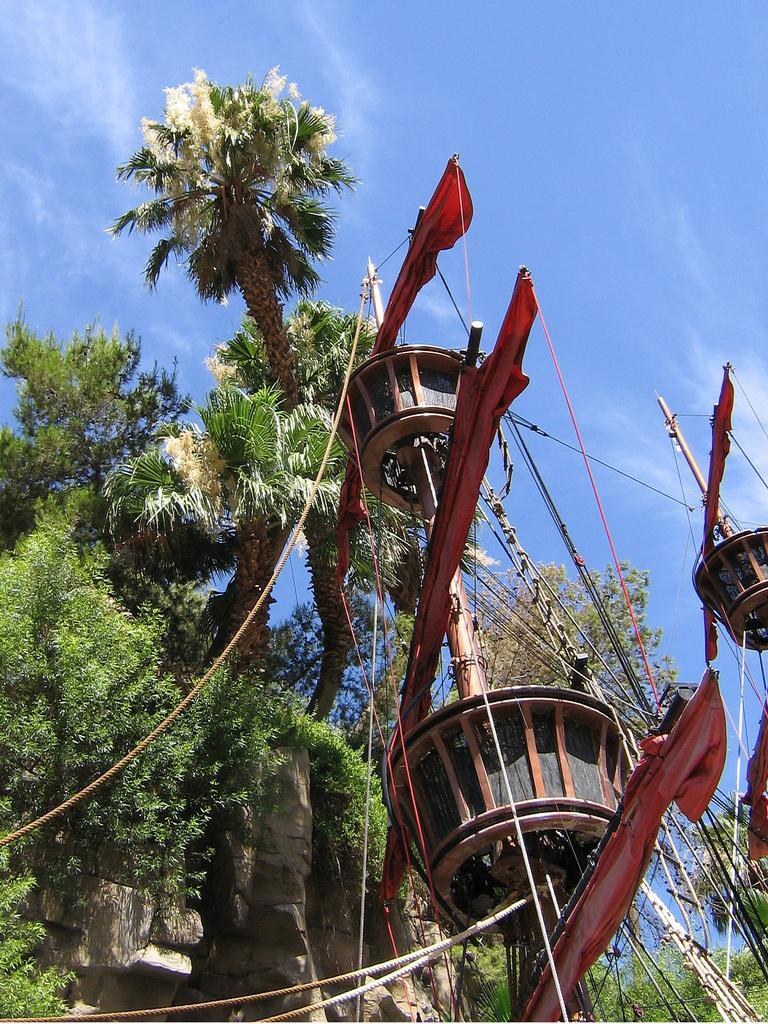Please provide a concise description of this image. In this image I can see the pirate ship which is in red color. I can see some ropes to it. In the background I can see many trees, clouds and the white sky. 